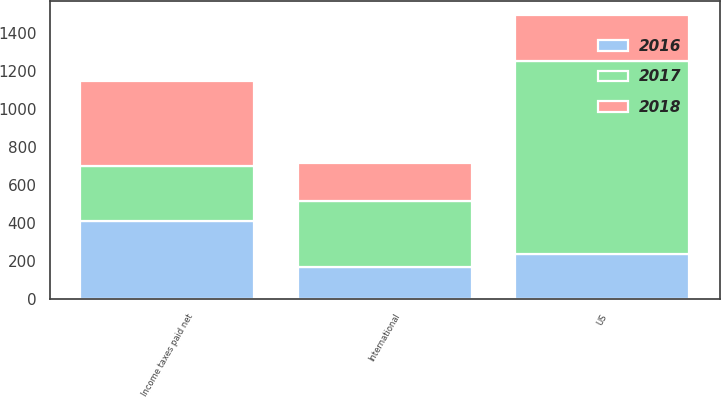Convert chart. <chart><loc_0><loc_0><loc_500><loc_500><stacked_bar_chart><ecel><fcel>US<fcel>International<fcel>Income taxes paid net<nl><fcel>2017<fcel>1016<fcel>345<fcel>293<nl><fcel>2016<fcel>239<fcel>171<fcel>410<nl><fcel>2018<fcel>241<fcel>203<fcel>444<nl></chart> 